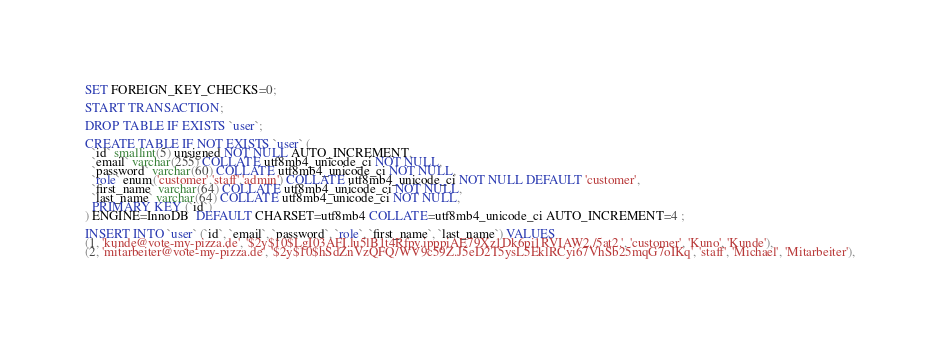<code> <loc_0><loc_0><loc_500><loc_500><_SQL_>SET FOREIGN_KEY_CHECKS=0;

START TRANSACTION;

DROP TABLE IF EXISTS `user`;

CREATE TABLE IF NOT EXISTS `user` (
  `id` smallint(5) unsigned NOT NULL AUTO_INCREMENT,
  `email` varchar(255) COLLATE utf8mb4_unicode_ci NOT NULL,
  `password` varchar(60) COLLATE utf8mb4_unicode_ci NOT NULL,
  `role` enum('customer','staff','admin') COLLATE utf8mb4_unicode_ci NOT NULL DEFAULT 'customer',
  `first_name` varchar(64) COLLATE utf8mb4_unicode_ci NOT NULL,
  `last_name` varchar(64) COLLATE utf8mb4_unicode_ci NOT NULL,
  PRIMARY KEY (`id`)
) ENGINE=InnoDB  DEFAULT CHARSET=utf8mb4 COLLATE=utf8mb4_unicode_ci AUTO_INCREMENT=4 ;

INSERT INTO `user` (`id`, `email`, `password`, `role`, `first_name`, `last_name`) VALUES
(1, 'kunde@vote-my-pizza.de', '$2y$10$LgI03AFI.lu5lB1t4Rfpy.ipppiAE79Xz1Dk6pi1RVIAW2./5at2.', 'customer', 'Kuno', 'Kunde'),
(2, 'mitarbeiter@vote-my-pizza.de', '$2y$10$hSdZnVzQFQ/WV9c59Z.J5eD2T5ysL5EklRCyi67VhSb25mqG7oIKq', 'staff', 'Michael', 'Mitarbeiter'),</code> 